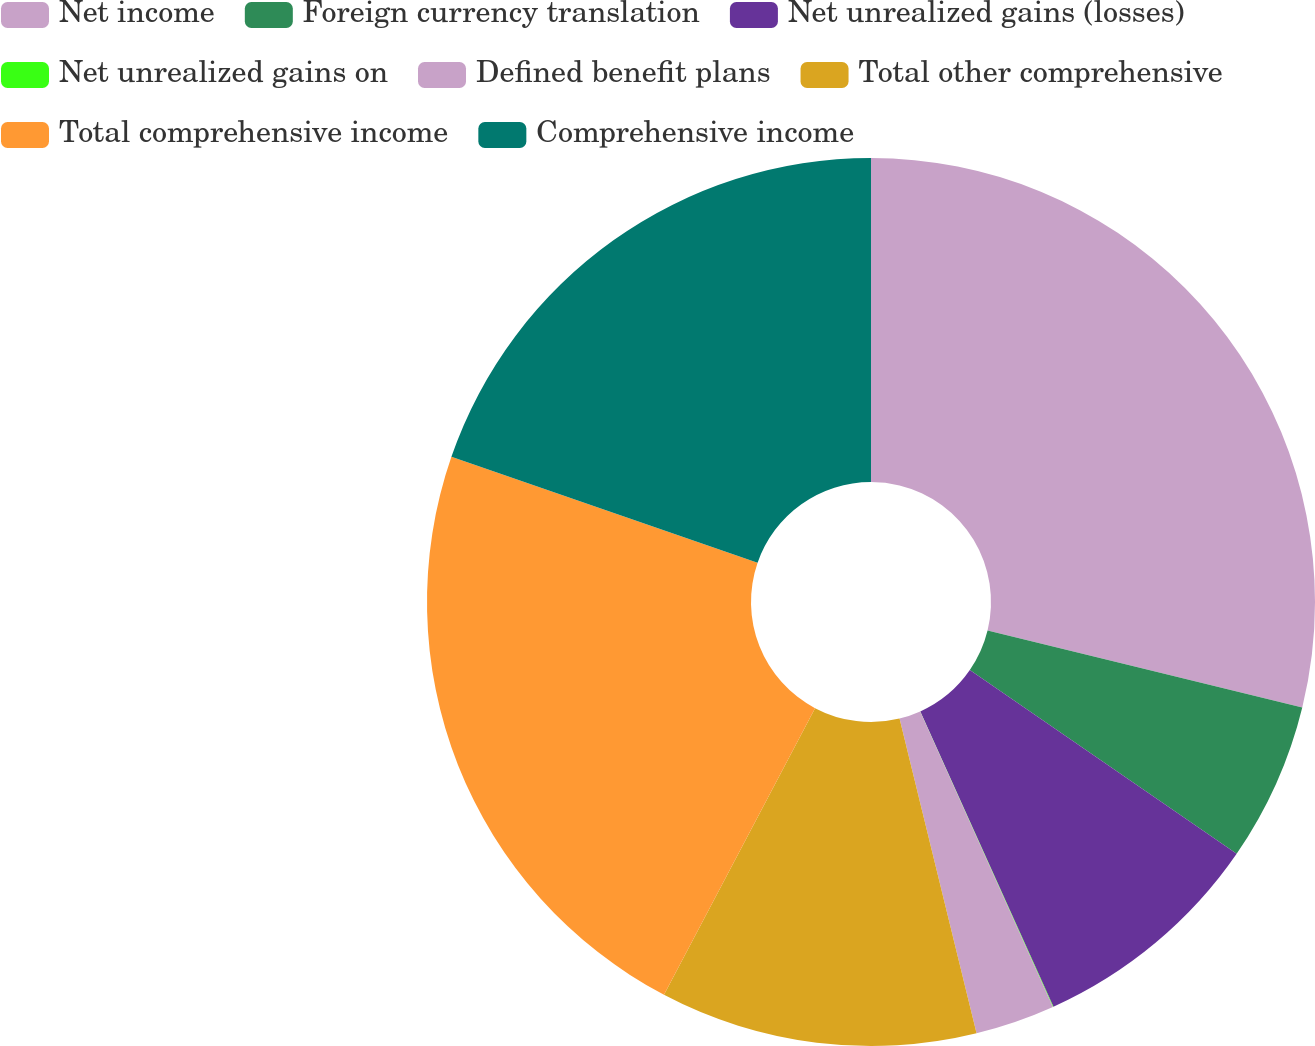Convert chart. <chart><loc_0><loc_0><loc_500><loc_500><pie_chart><fcel>Net income<fcel>Foreign currency translation<fcel>Net unrealized gains (losses)<fcel>Net unrealized gains on<fcel>Defined benefit plans<fcel>Total other comprehensive<fcel>Total comprehensive income<fcel>Comprehensive income<nl><fcel>28.82%<fcel>5.78%<fcel>8.66%<fcel>0.02%<fcel>2.9%<fcel>11.54%<fcel>22.58%<fcel>19.7%<nl></chart> 